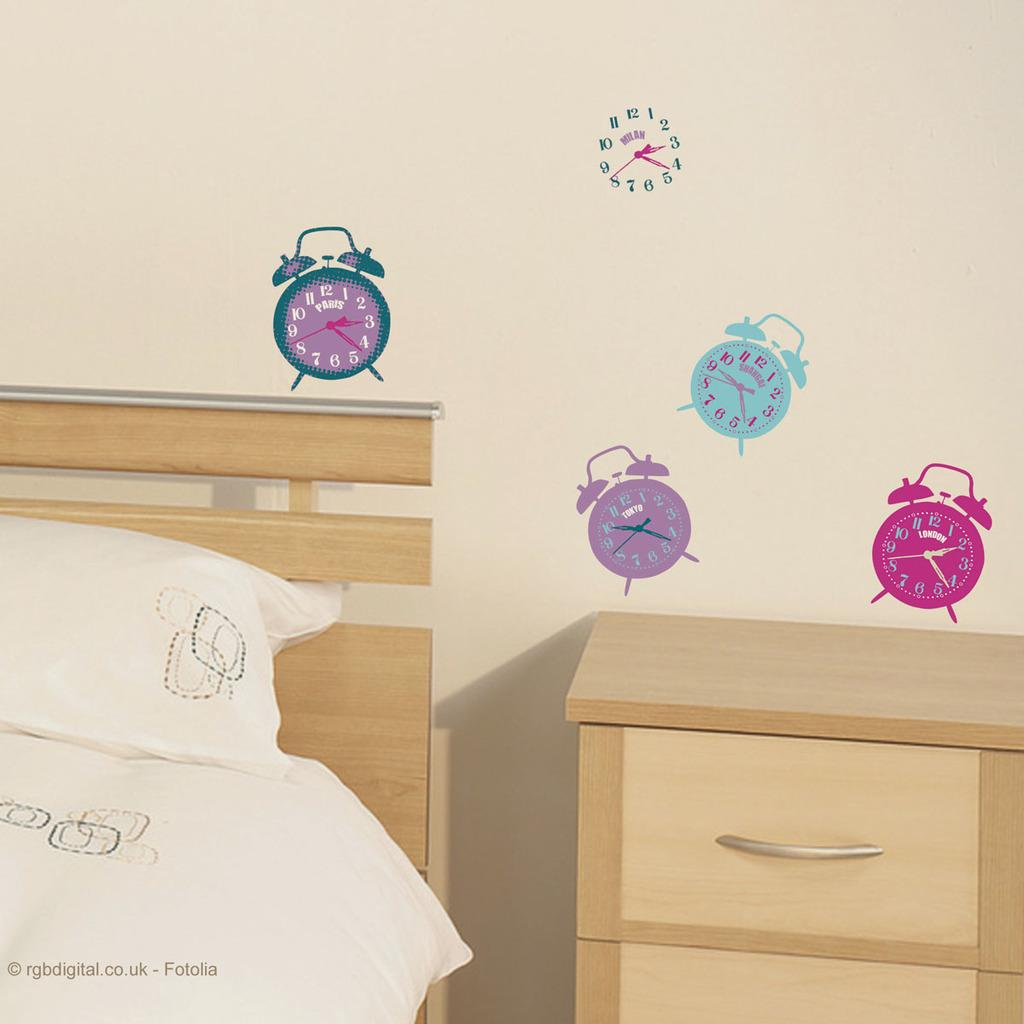<image>
Summarize the visual content of the image. A bedroom has clock decals on the wall which show the time in different cities. 